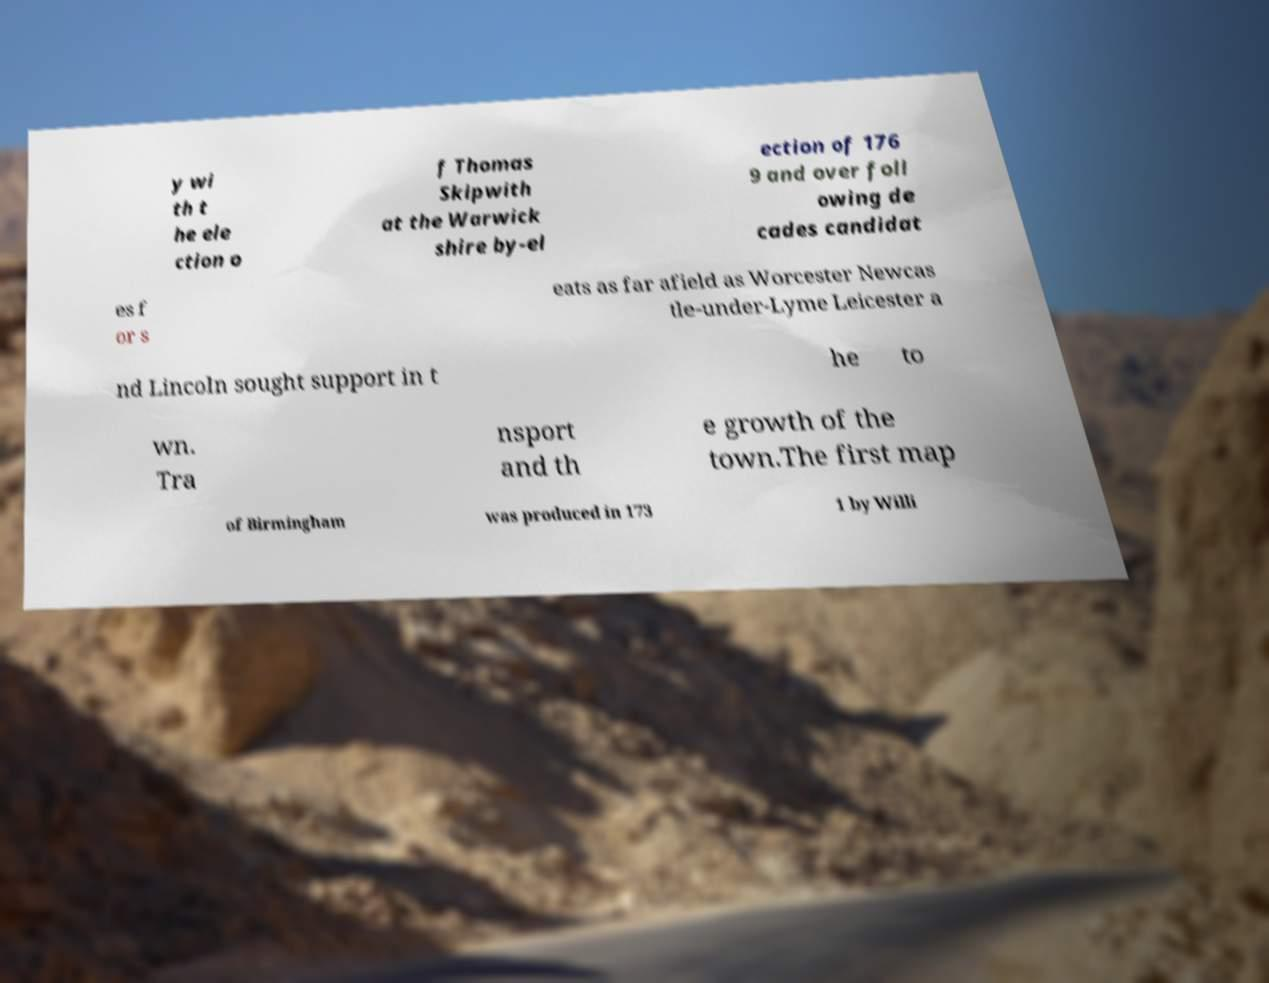Can you accurately transcribe the text from the provided image for me? y wi th t he ele ction o f Thomas Skipwith at the Warwick shire by-el ection of 176 9 and over foll owing de cades candidat es f or s eats as far afield as Worcester Newcas tle-under-Lyme Leicester a nd Lincoln sought support in t he to wn. Tra nsport and th e growth of the town.The first map of Birmingham was produced in 173 1 by Willi 